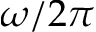Convert formula to latex. <formula><loc_0><loc_0><loc_500><loc_500>\omega / 2 \pi</formula> 